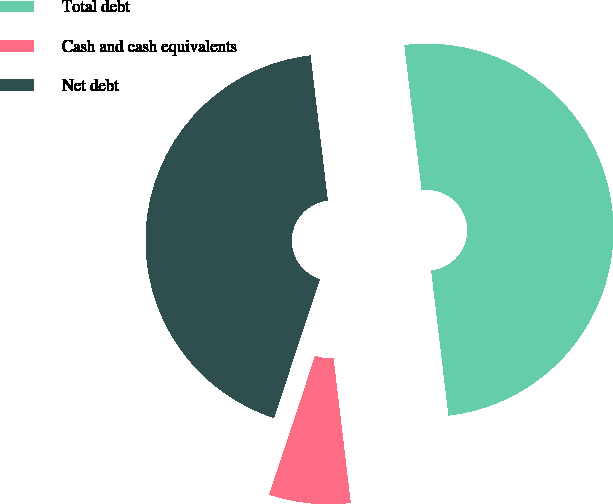Convert chart. <chart><loc_0><loc_0><loc_500><loc_500><pie_chart><fcel>Total debt<fcel>Cash and cash equivalents<fcel>Net debt<nl><fcel>50.0%<fcel>6.97%<fcel>43.03%<nl></chart> 